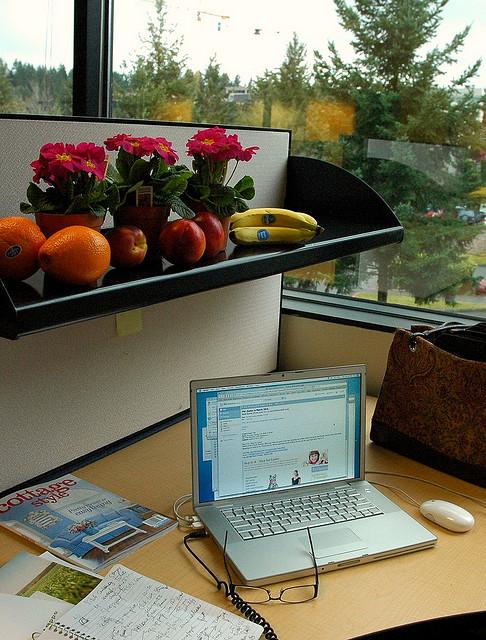What is plugged into the laptop?
Short answer required. Mouse. Is the laptop computer working?
Be succinct. Yes. How many open laptops?
Answer briefly. 1. What object is in front of the keyboard?
Short answer required. Glasses. What is the name of the magazine on the table called?
Short answer required. Cottage. 